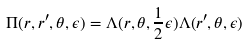Convert formula to latex. <formula><loc_0><loc_0><loc_500><loc_500>\Pi ( r , r ^ { \prime } , \theta , \epsilon ) = \Lambda ( r , \theta , \frac { 1 } { 2 } \epsilon ) \Lambda ( r ^ { \prime } , \theta , \epsilon )</formula> 